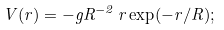Convert formula to latex. <formula><loc_0><loc_0><loc_500><loc_500>V ( r ) = - g R ^ { - 2 } \, r \exp ( - r / R ) ;</formula> 